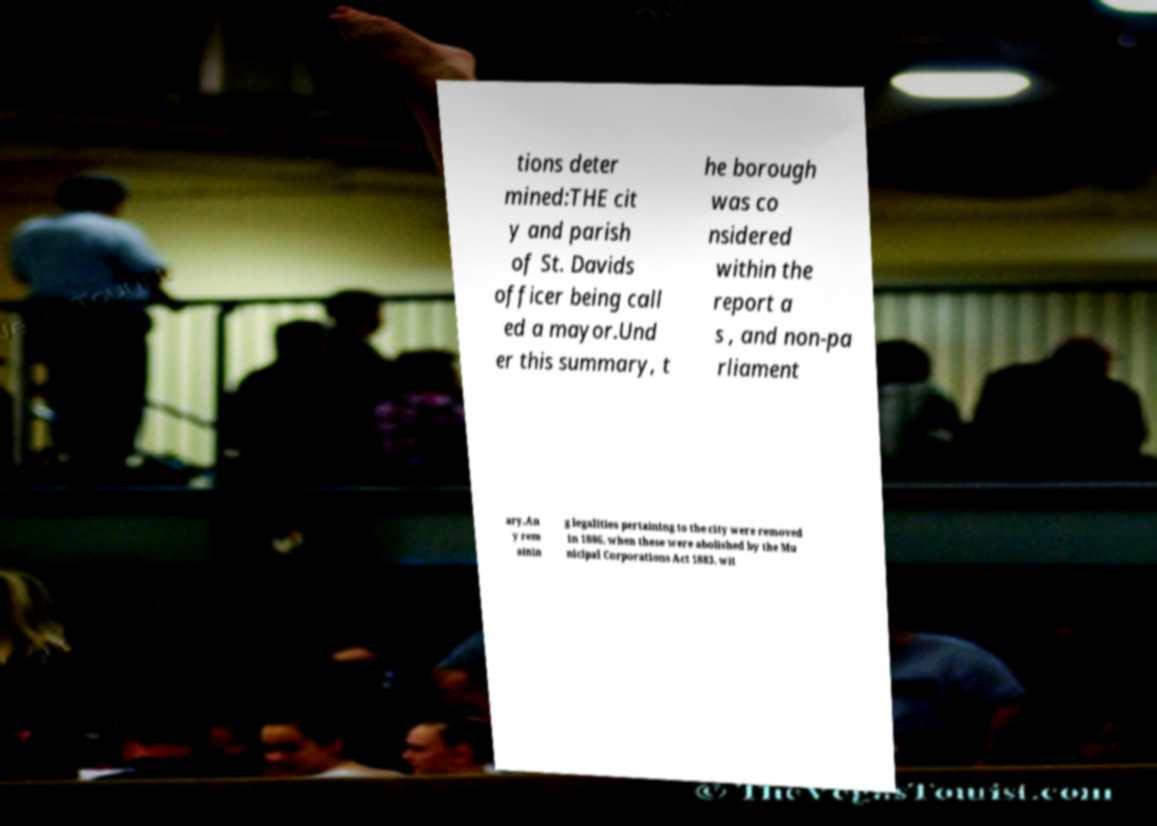There's text embedded in this image that I need extracted. Can you transcribe it verbatim? tions deter mined:THE cit y and parish of St. Davids officer being call ed a mayor.Und er this summary, t he borough was co nsidered within the report a s , and non-pa rliament ary.An y rem ainin g legalities pertaining to the city were removed in 1886, when these were abolished by the Mu nicipal Corporations Act 1883, wit 